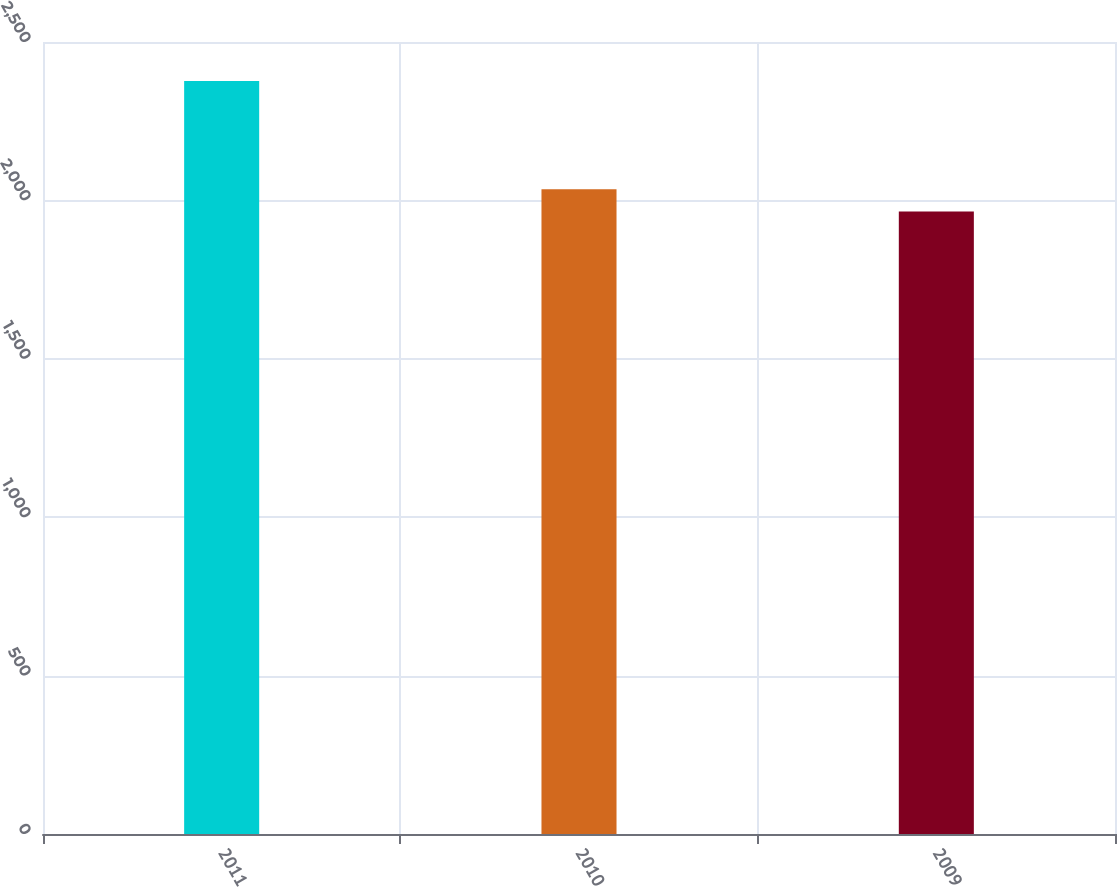Convert chart to OTSL. <chart><loc_0><loc_0><loc_500><loc_500><bar_chart><fcel>2011<fcel>2010<fcel>2009<nl><fcel>2377<fcel>2035<fcel>1965<nl></chart> 